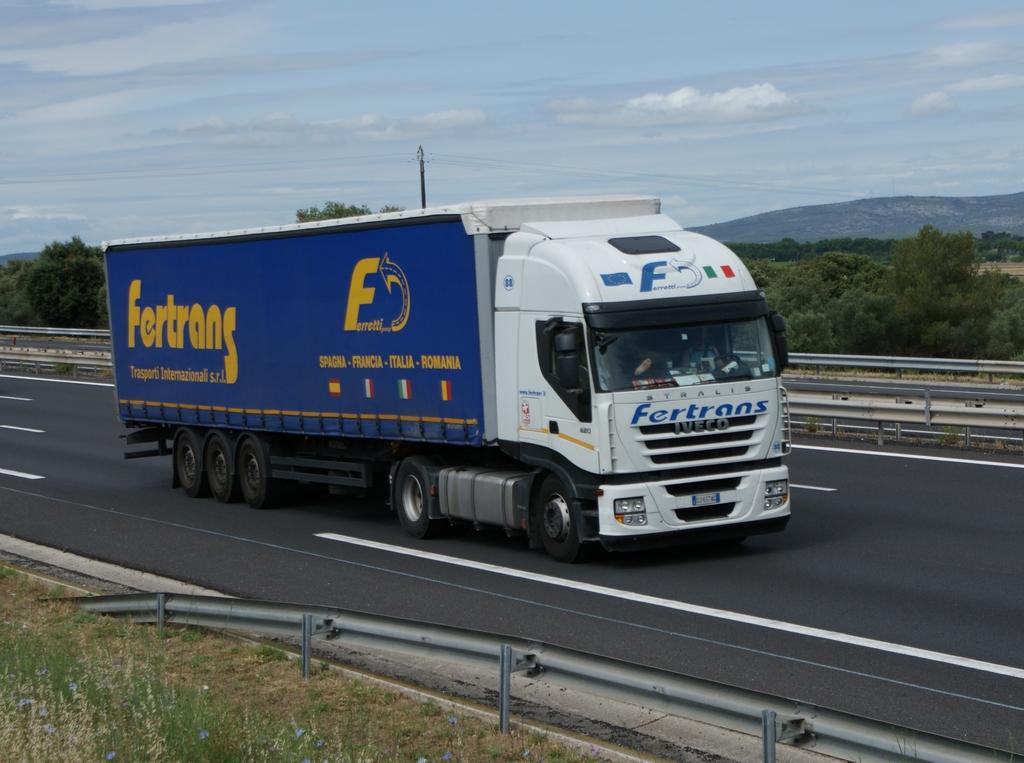What is on the road in the image? There is a vehicle on the road in the image. What type of barrier is visible in the image? There is railing visible in the image. What type of vegetation is present in the image? Grass and trees are visible in the image. What structure can be seen in the image? There is a pole in the image. What is visible in the background of the image? A mountain and the sky are visible in the background of the image. What can be seen in the sky in the image? Clouds are present in the sky. What type of cabbage is being cooked in the image? There is no cabbage or cooking activity present in the image. What type of cream is being used to decorate the mountain in the image? There is no cream or decoration present on the mountain in the image. 